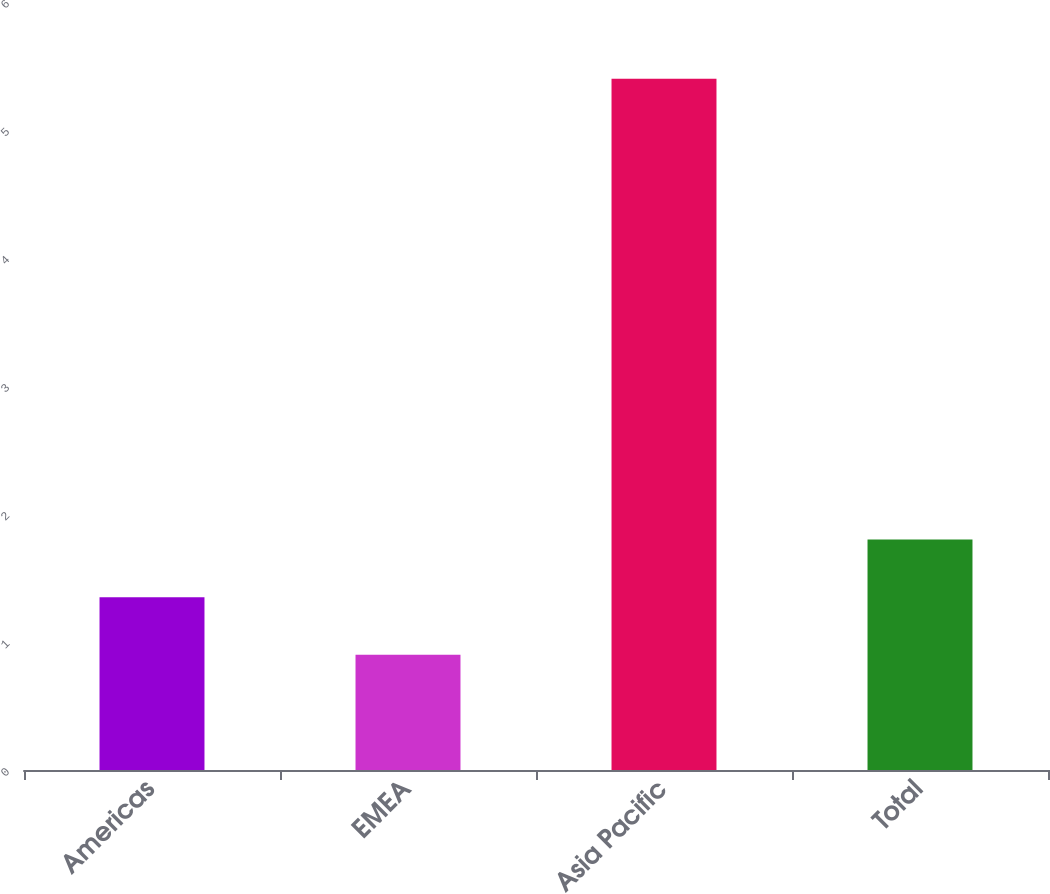Convert chart to OTSL. <chart><loc_0><loc_0><loc_500><loc_500><bar_chart><fcel>Americas<fcel>EMEA<fcel>Asia Pacific<fcel>Total<nl><fcel>1.35<fcel>0.9<fcel>5.4<fcel>1.8<nl></chart> 